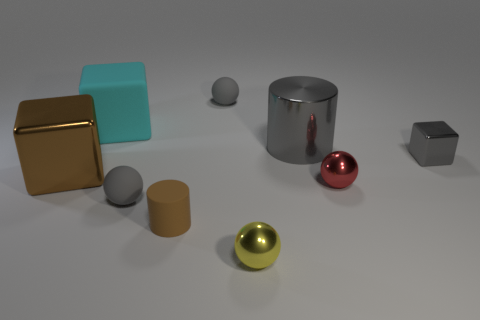Subtract 1 spheres. How many spheres are left? 3 Subtract all blocks. How many objects are left? 6 Add 1 small metallic things. How many small metallic things are left? 4 Add 5 small gray matte things. How many small gray matte things exist? 7 Subtract 1 cyan blocks. How many objects are left? 8 Subtract all big metallic things. Subtract all gray cylinders. How many objects are left? 6 